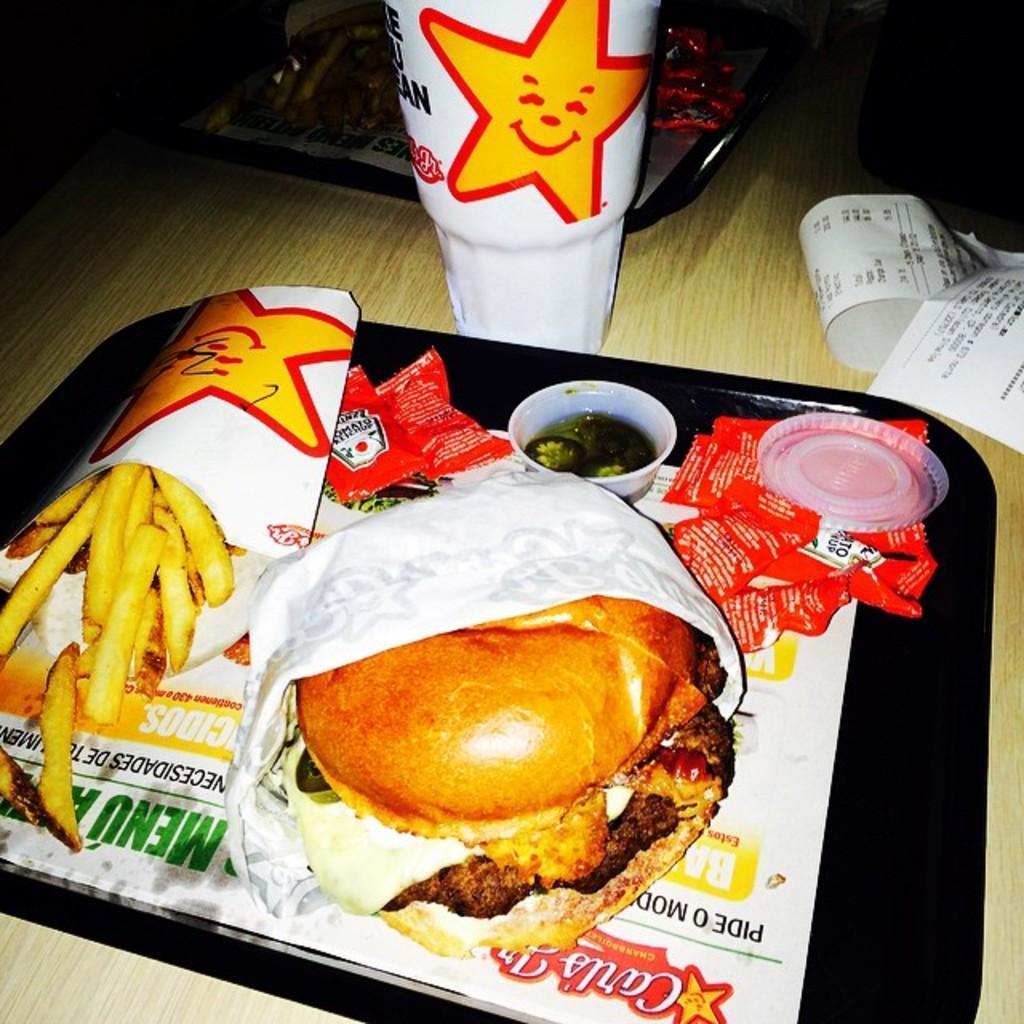In one or two sentences, can you explain what this image depicts? In this picture I can see there is a tray of food, there are fries, burger and there is a disposable glass. There is another tray of food in the backdrop. They are placed on the table. 